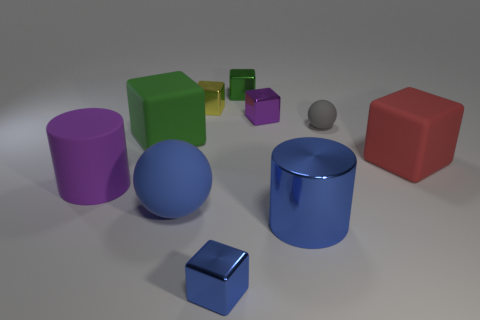What is the color of the small sphere?
Provide a short and direct response. Gray. The rubber cylinder that is the same size as the red matte object is what color?
Provide a succinct answer. Purple. Is there a large metal thing of the same color as the large rubber cylinder?
Offer a terse response. No. Does the tiny object that is in front of the gray ball have the same shape as the tiny thing on the right side of the blue cylinder?
Your response must be concise. No. There is a cube that is the same color as the big matte sphere; what is its size?
Offer a very short reply. Small. How many other things are there of the same size as the yellow block?
Make the answer very short. 4. Is the color of the big metal object the same as the rubber sphere that is behind the blue rubber thing?
Offer a terse response. No. Is the number of blue blocks right of the small blue block less than the number of matte things left of the gray sphere?
Ensure brevity in your answer.  Yes. The object that is behind the big green matte object and to the right of the purple metal block is what color?
Provide a short and direct response. Gray. There is a yellow object; is its size the same as the matte ball to the right of the small purple metal thing?
Your answer should be very brief. Yes. 